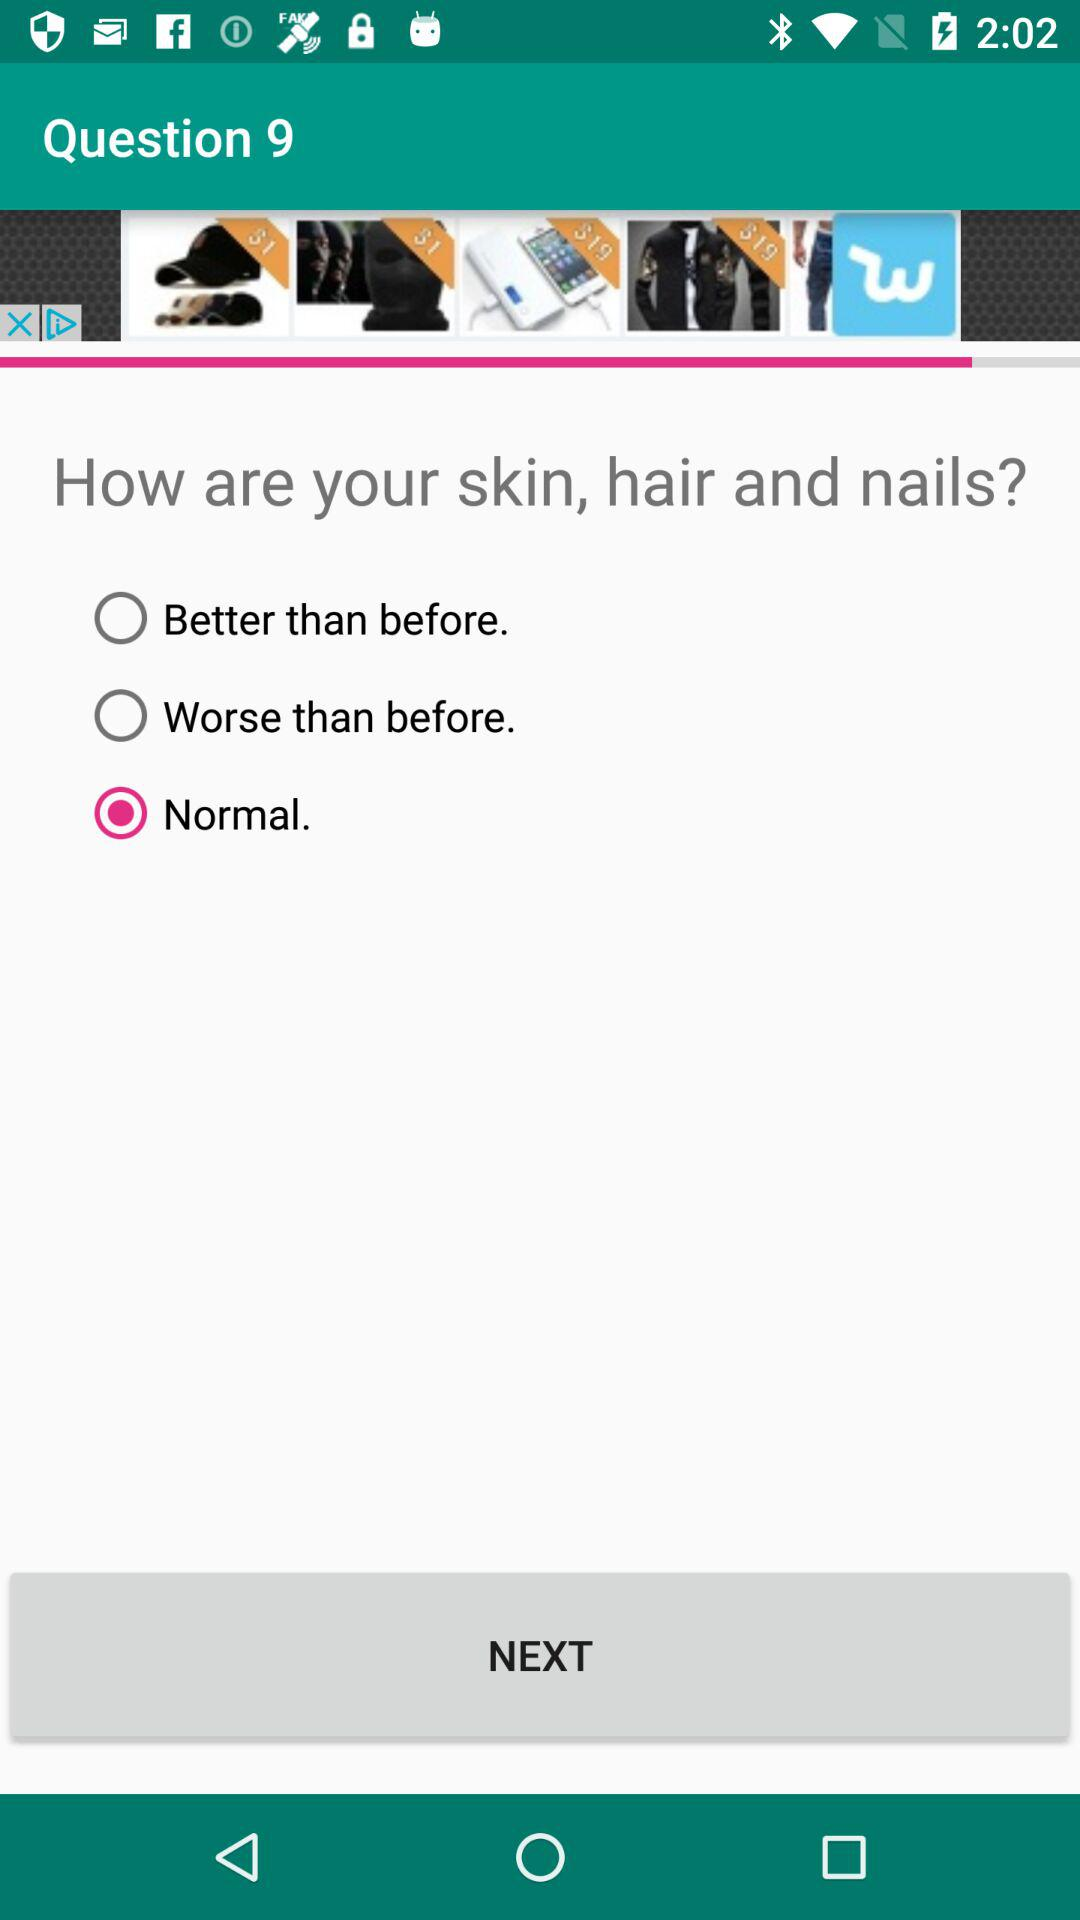Which answer has been selected? The selected answer is "Normal". 